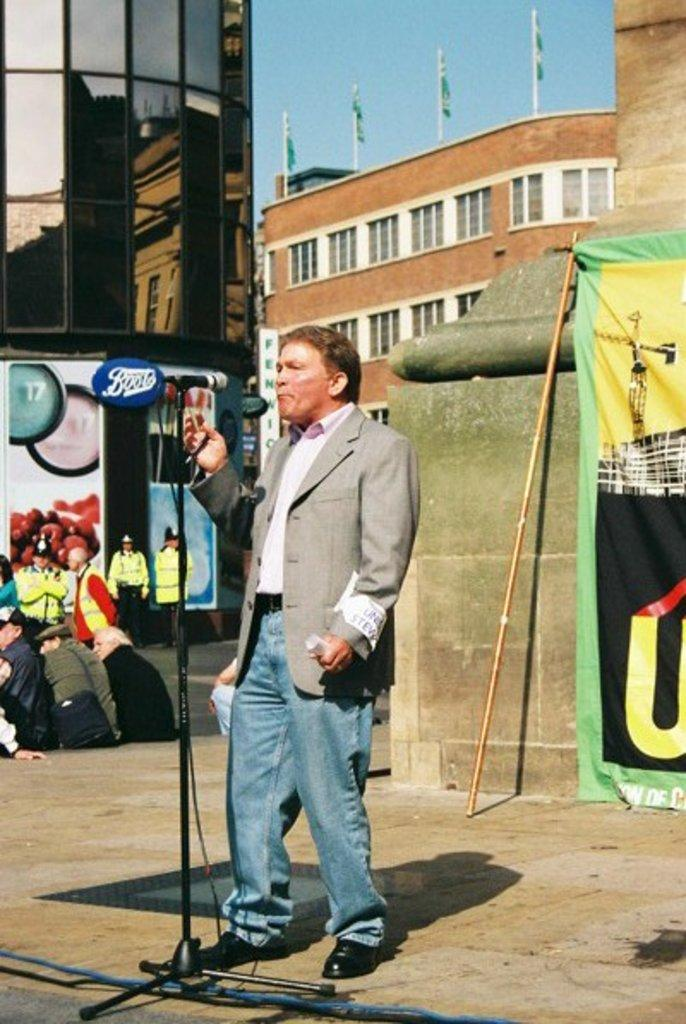What is the main subject of the image? There is a man in the middle of the image. What is the man wearing? The man is wearing a suit, a shirt, and trousers. What is in front of the man? There is a microphone in front of the man. What can be seen in the background of the image? There are people, flags, buildings, poles, and the sky visible in the background of the image. Is there a boat visible in the image? No, there is no boat present in the image. What type of health issues can be seen affecting the man in the image? There is no indication of any health issues affecting the man in the image. 